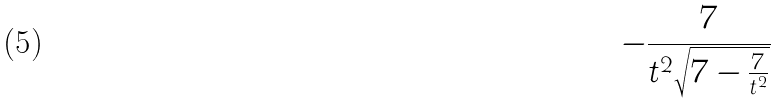Convert formula to latex. <formula><loc_0><loc_0><loc_500><loc_500>- \frac { 7 } { t ^ { 2 } \sqrt { 7 - \frac { 7 } { t ^ { 2 } } } }</formula> 